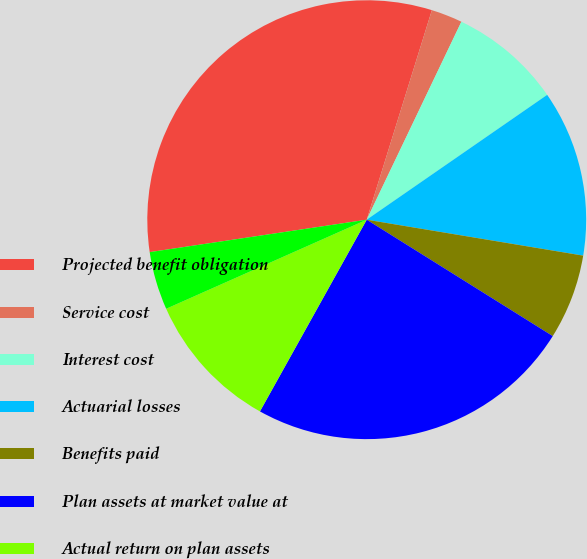<chart> <loc_0><loc_0><loc_500><loc_500><pie_chart><fcel>Projected benefit obligation<fcel>Service cost<fcel>Interest cost<fcel>Actuarial losses<fcel>Benefits paid<fcel>Plan assets at market value at<fcel>Actual return on plan assets<fcel>Contribution<nl><fcel>32.16%<fcel>2.3%<fcel>8.27%<fcel>12.25%<fcel>6.28%<fcel>24.19%<fcel>10.26%<fcel>4.29%<nl></chart> 